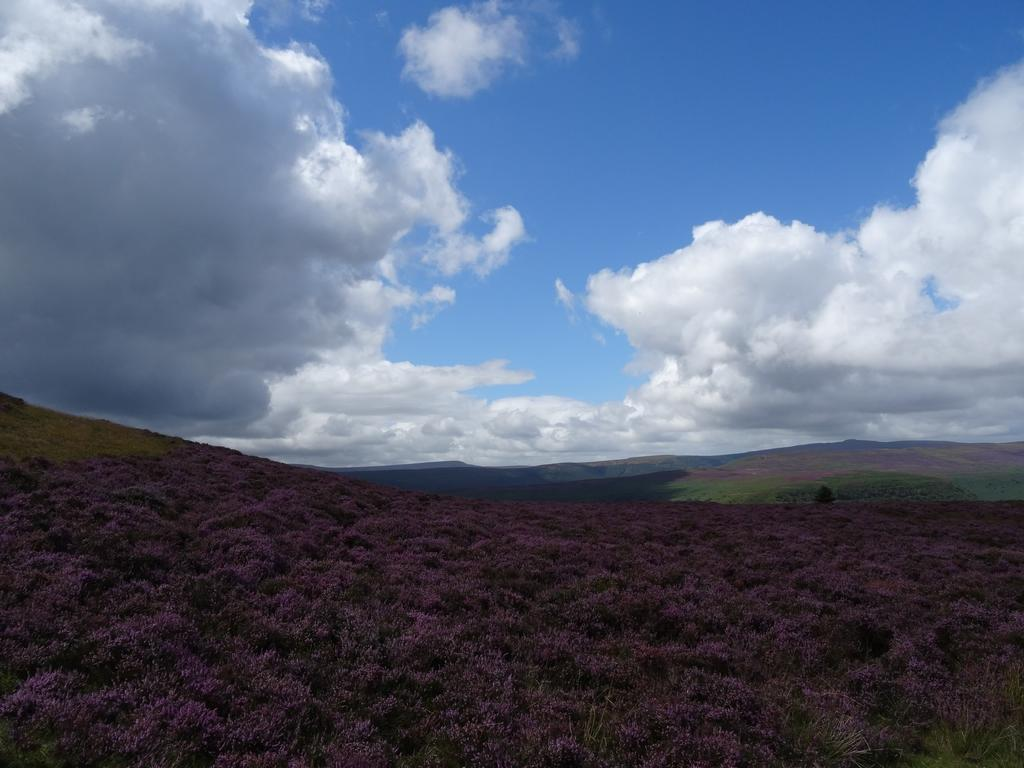What celestial bodies are depicted in the picture? There are planets in the picture. What type of natural landforms can be seen in the picture? There are hills in the picture. What is visible in the background of the picture? The sky is visible in the background of the picture. What can be observed in the sky in the picture? Clouds are present in the sky. Where are the friends sitting in the picture? There are no friends present in the picture; it features planets and hills. What type of flower can be seen growing near the planets in the picture? There are no flowers, including roses, depicted in the picture; it only features planets and hills. 